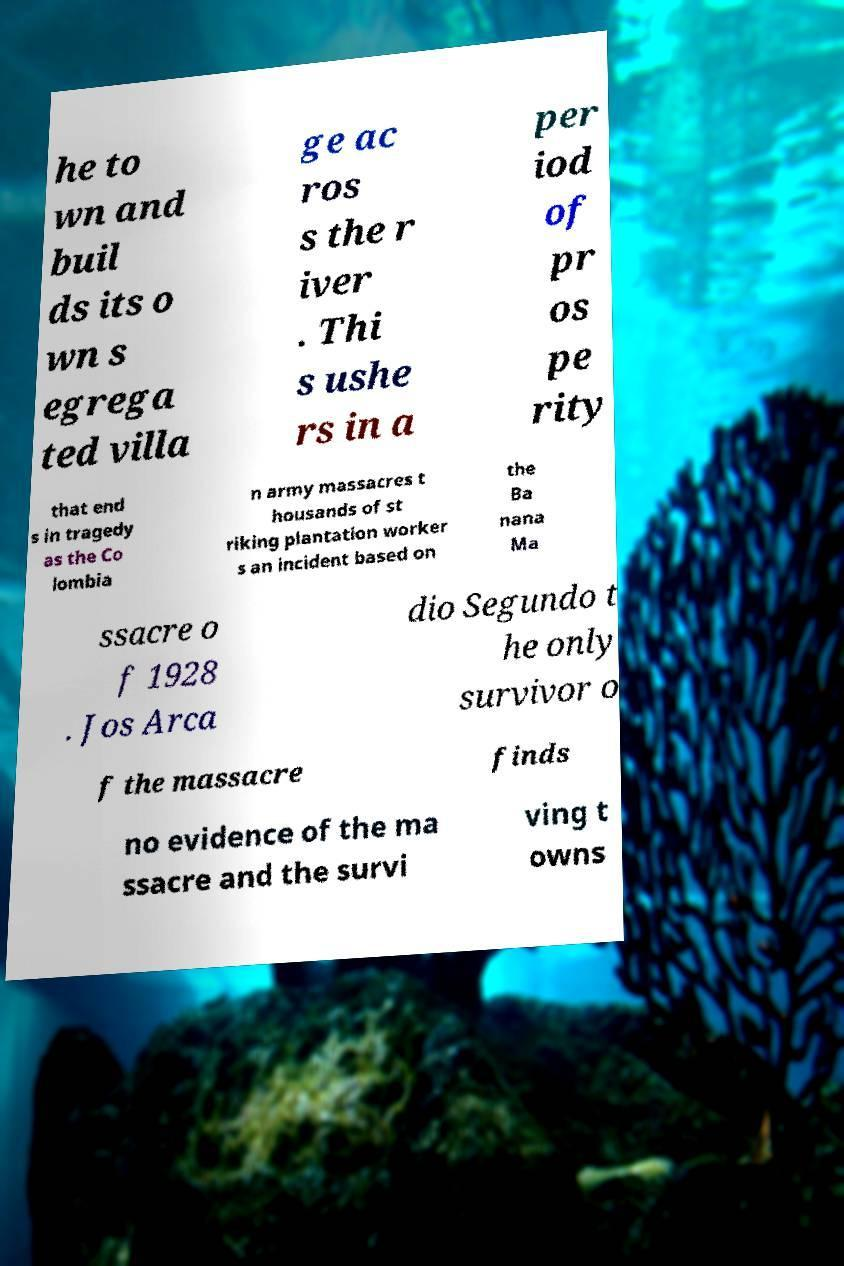Please read and relay the text visible in this image. What does it say? he to wn and buil ds its o wn s egrega ted villa ge ac ros s the r iver . Thi s ushe rs in a per iod of pr os pe rity that end s in tragedy as the Co lombia n army massacres t housands of st riking plantation worker s an incident based on the Ba nana Ma ssacre o f 1928 . Jos Arca dio Segundo t he only survivor o f the massacre finds no evidence of the ma ssacre and the survi ving t owns 